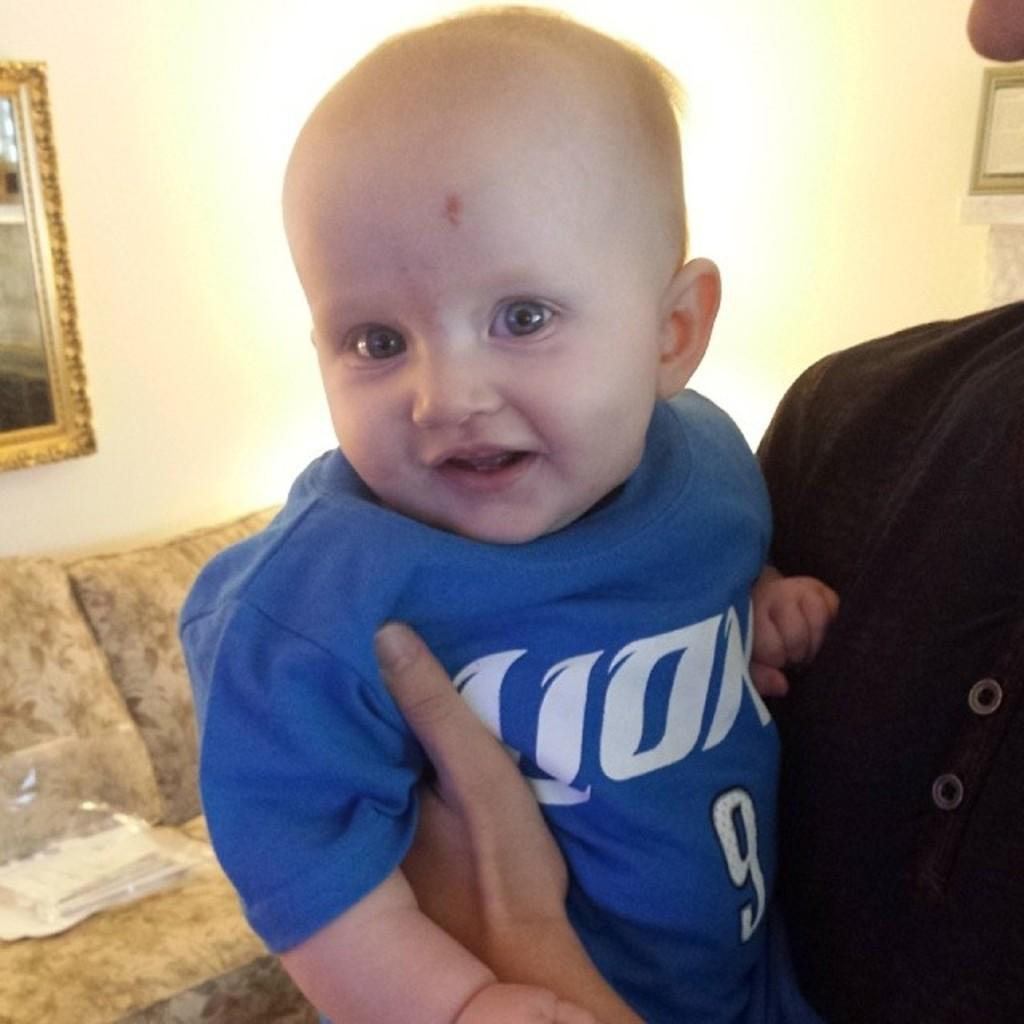<image>
Describe the image concisely. A baby wearing a Lion number 9 shirt being held in a living room. 